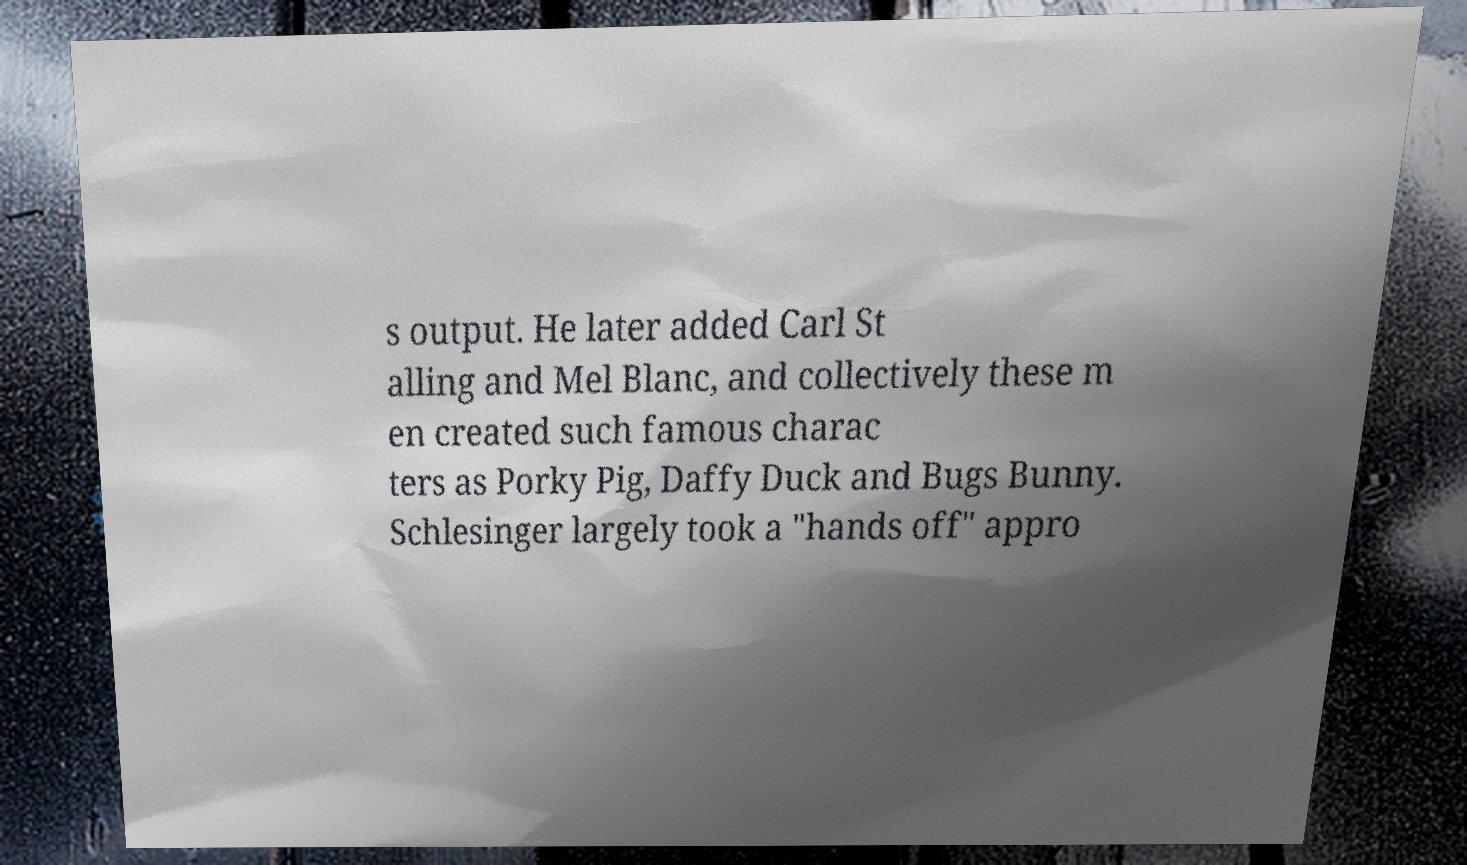For documentation purposes, I need the text within this image transcribed. Could you provide that? s output. He later added Carl St alling and Mel Blanc, and collectively these m en created such famous charac ters as Porky Pig, Daffy Duck and Bugs Bunny. Schlesinger largely took a "hands off" appro 